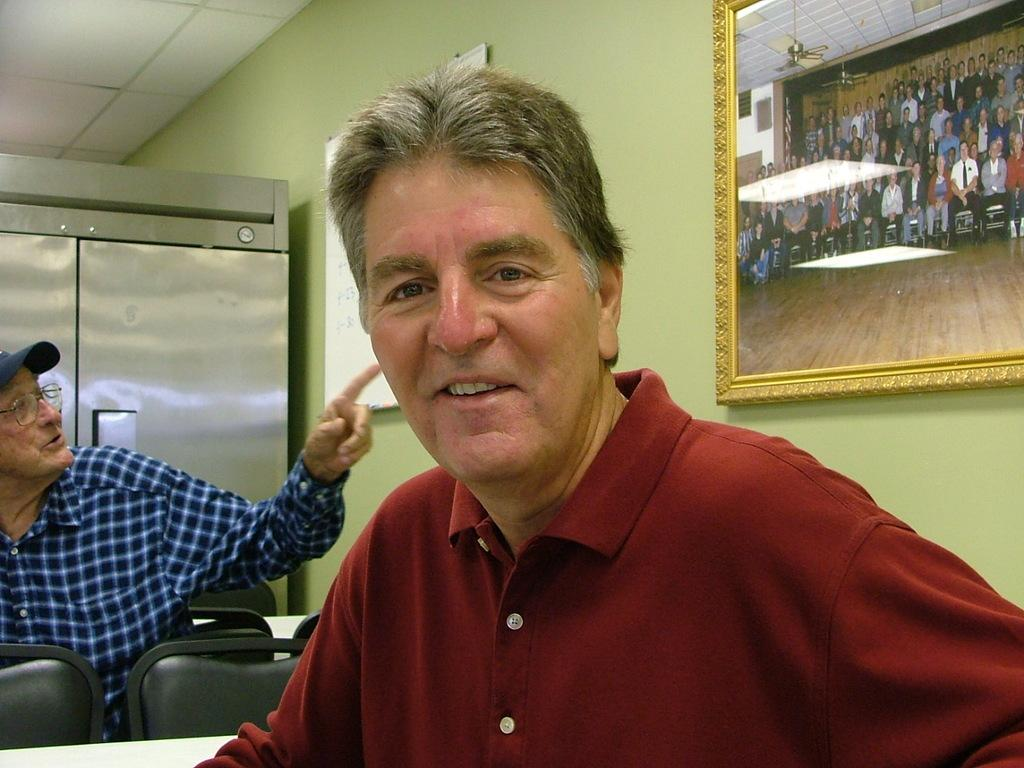How many men are in the image? There are two men in the image. What type of furniture is present in the image? There are tables and chairs in the image. What architectural features can be seen in the image? There is a wall, a frame, a board, a ceiling, a cupboard, and a floor in the image. What is the purpose of the frame in the image? In the frame, there is a group of people. What type of appliances are visible in the image? There are fans in the image. What type of ground can be seen in the image? There is no ground visible in the image; it takes place indoors. Is there a scarecrow present in the image? No, there is no scarecrow present in the image. 